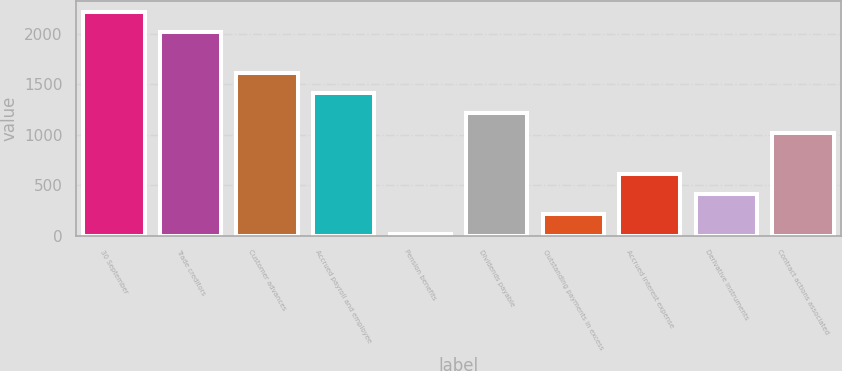Convert chart to OTSL. <chart><loc_0><loc_0><loc_500><loc_500><bar_chart><fcel>30 September<fcel>Trade creditors<fcel>Customer advances<fcel>Accrued payroll and employee<fcel>Pension benefits<fcel>Dividends payable<fcel>Outstanding payments in excess<fcel>Accrued interest expense<fcel>Derivative instruments<fcel>Contract actions associated<nl><fcel>2211.85<fcel>2012<fcel>1612.3<fcel>1412.45<fcel>13.5<fcel>1212.6<fcel>213.35<fcel>613.05<fcel>413.2<fcel>1012.75<nl></chart> 